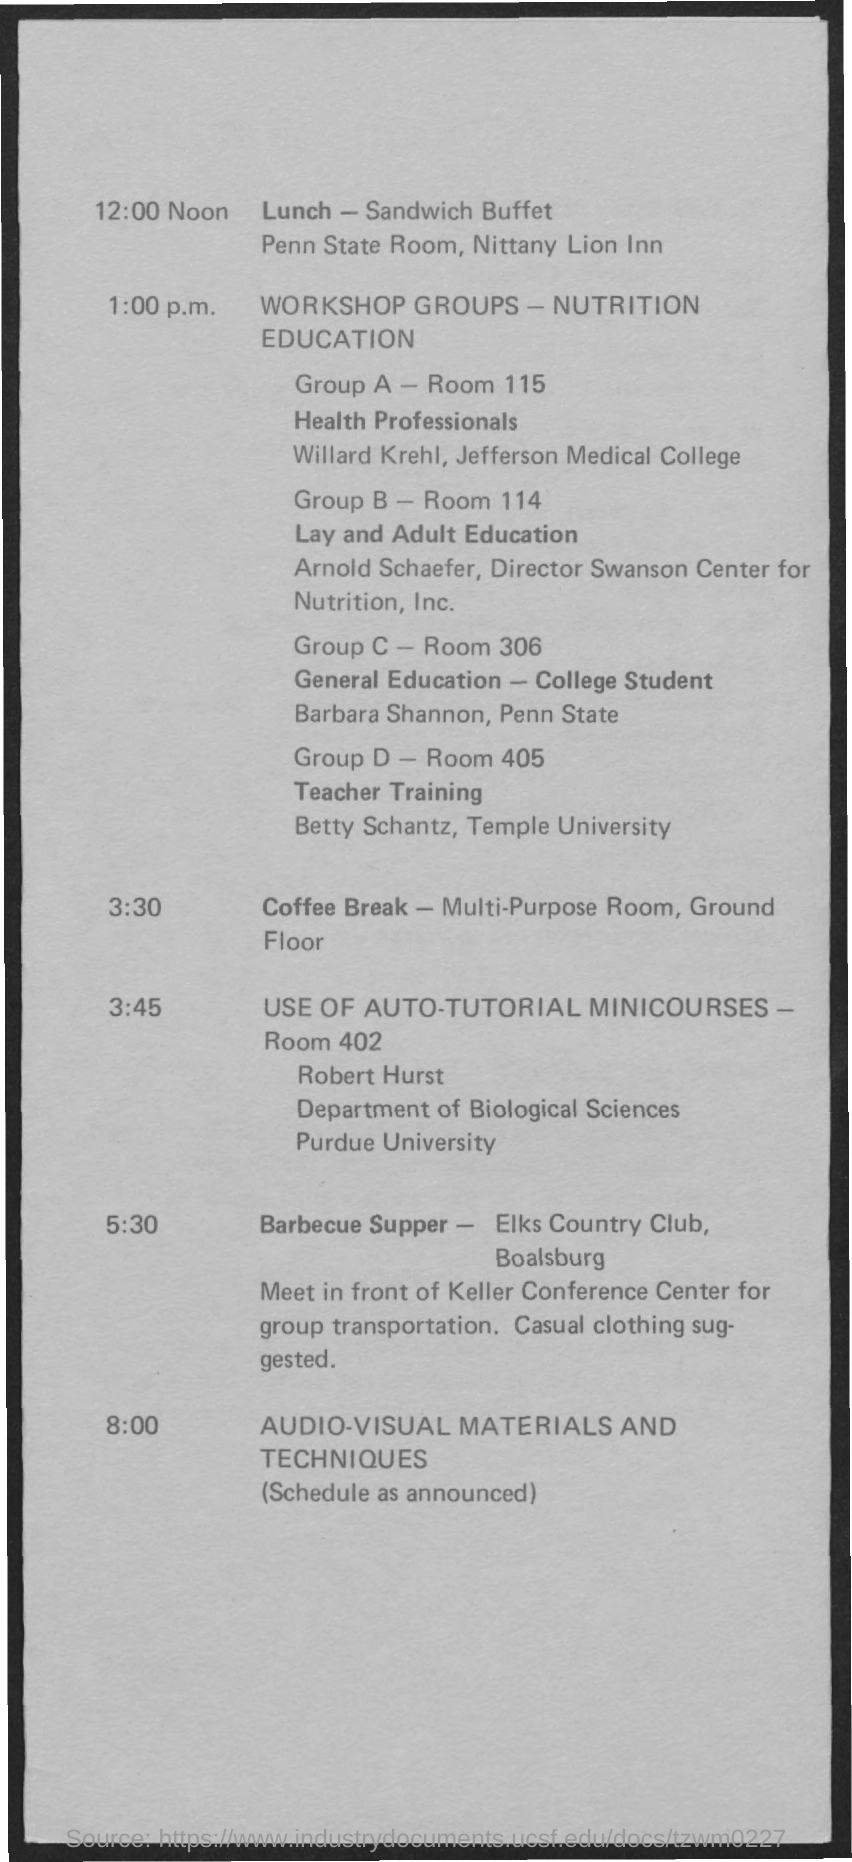Lunch is scheduled at which time?
Offer a very short reply. 12:00 Noon. What is the room number of Group A?
Your answer should be compact. 115. Coffee Break is on which time?
Offer a terse response. 3:30. Barbecue Supper is on which time?
Your answer should be compact. 5:30. What is the room number of Group D?
Provide a short and direct response. 405. 